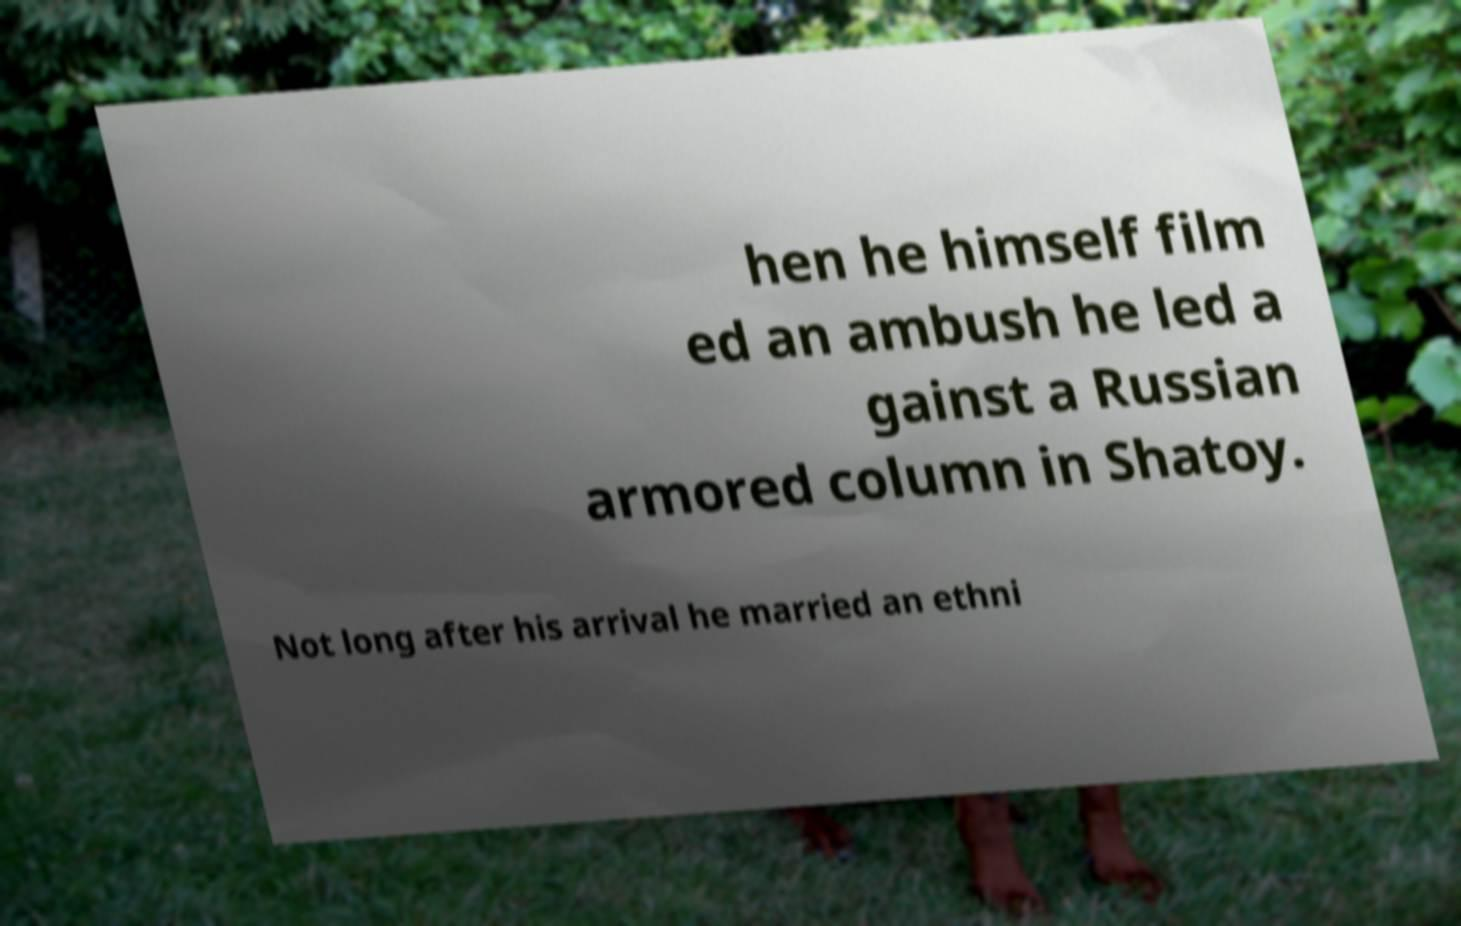What messages or text are displayed in this image? I need them in a readable, typed format. hen he himself film ed an ambush he led a gainst a Russian armored column in Shatoy. Not long after his arrival he married an ethni 